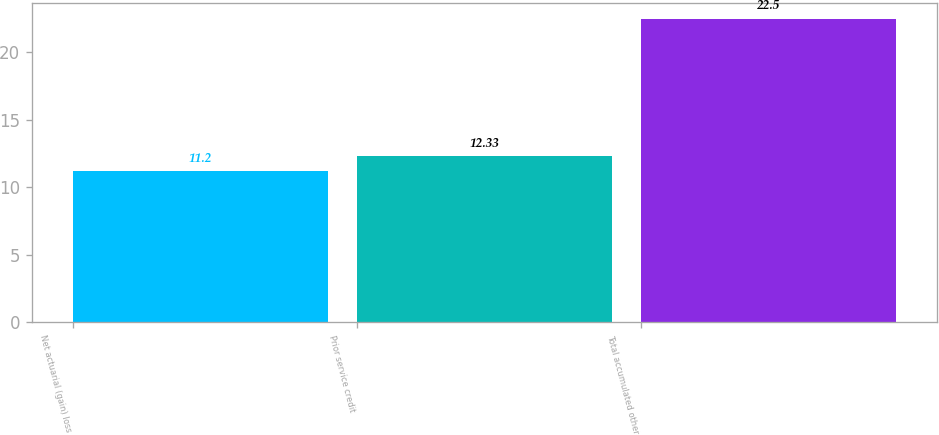Convert chart. <chart><loc_0><loc_0><loc_500><loc_500><bar_chart><fcel>Net actuarial (gain) loss<fcel>Prior service credit<fcel>Total accumulated other<nl><fcel>11.2<fcel>12.33<fcel>22.5<nl></chart> 